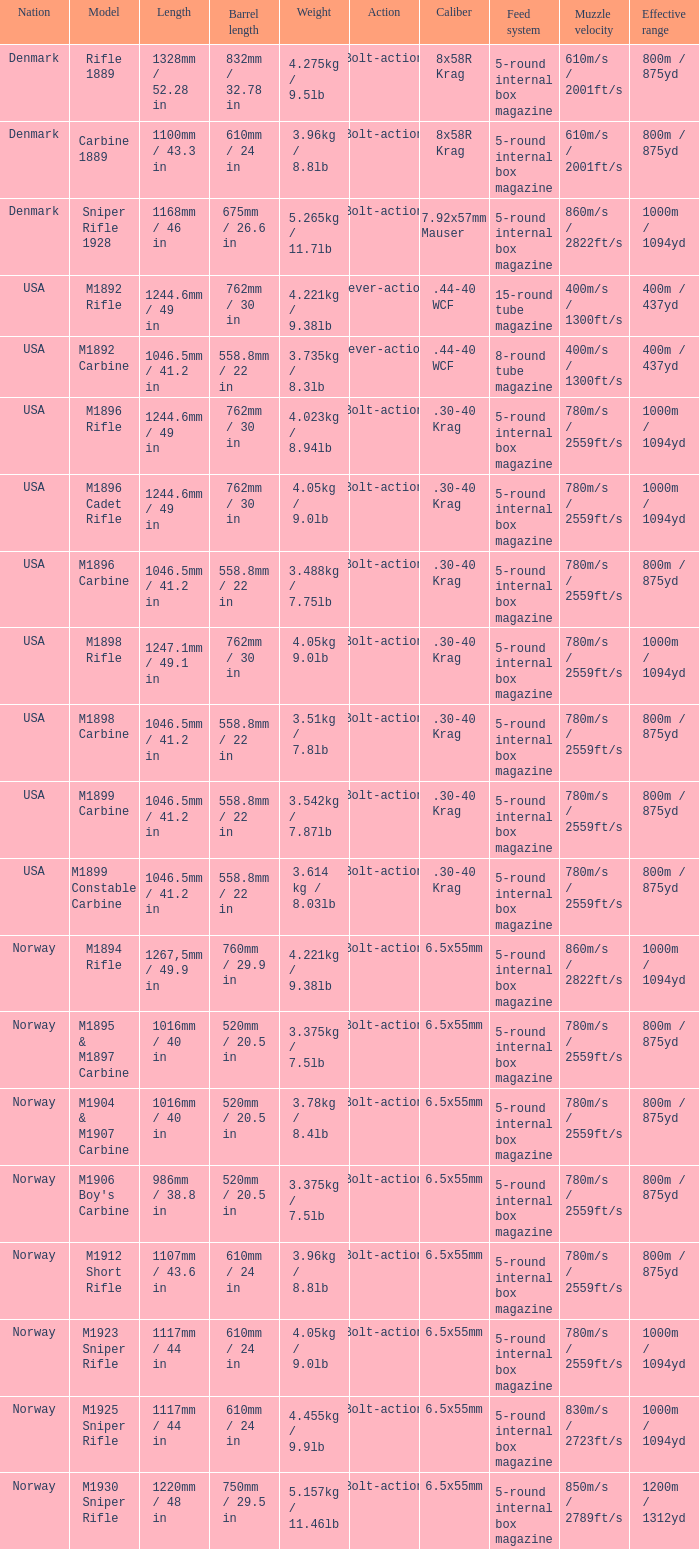What is the distance, when the barrel's extent is 750mm / 2 1220mm / 48 in. 